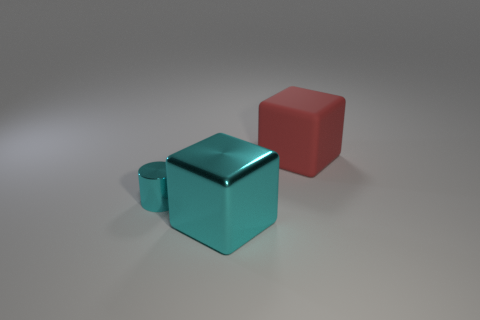Do the red thing and the cyan object that is behind the cyan cube have the same size?
Offer a terse response. No. There is a matte thing that is behind the large object to the left of the red cube; what color is it?
Your response must be concise. Red. How many other things are there of the same color as the tiny thing?
Make the answer very short. 1. The cyan cube is what size?
Offer a terse response. Large. Are there more matte blocks that are behind the tiny cyan thing than matte blocks that are in front of the big cyan metal object?
Give a very brief answer. Yes. There is a cube in front of the cylinder; how many big cubes are on the right side of it?
Your answer should be compact. 1. There is a thing right of the cyan block; is it the same shape as the large cyan shiny thing?
Offer a very short reply. Yes. There is another cyan thing that is the same shape as the rubber object; what is its material?
Make the answer very short. Metal. What number of other things have the same size as the rubber object?
Offer a terse response. 1. What color is the object that is on the right side of the tiny cyan thing and behind the large cyan metal thing?
Offer a very short reply. Red. 